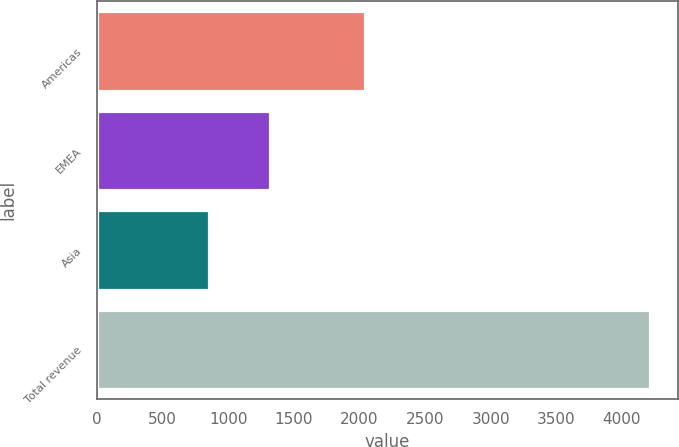<chart> <loc_0><loc_0><loc_500><loc_500><bar_chart><fcel>Americas<fcel>EMEA<fcel>Asia<fcel>Total revenue<nl><fcel>2044.6<fcel>1317.4<fcel>854.3<fcel>4216.3<nl></chart> 